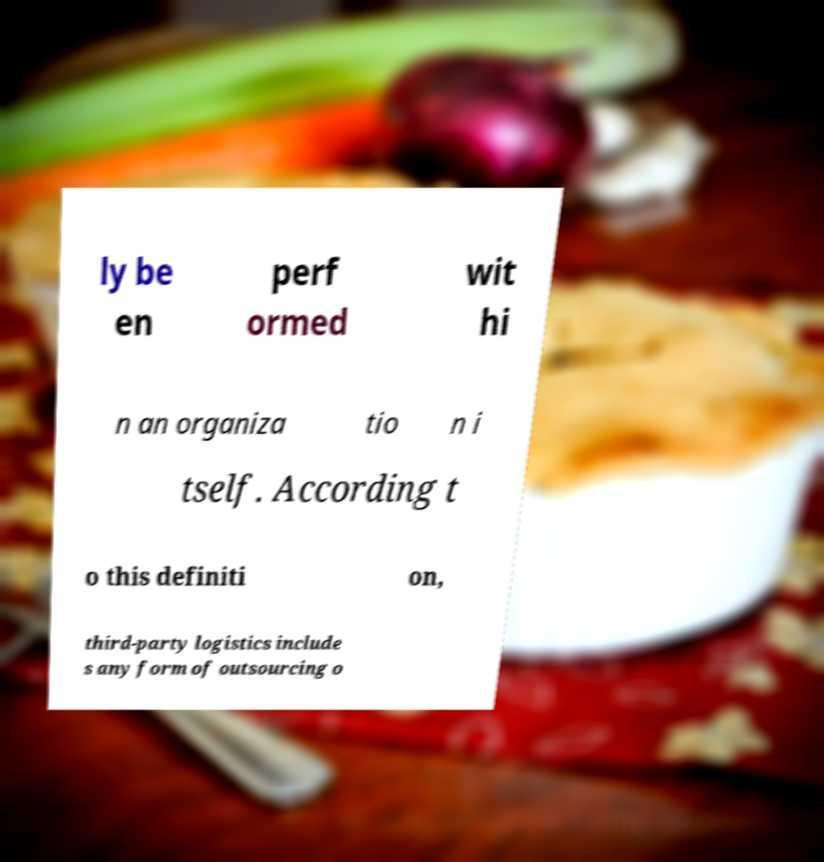Could you extract and type out the text from this image? ly be en perf ormed wit hi n an organiza tio n i tself. According t o this definiti on, third-party logistics include s any form of outsourcing o 